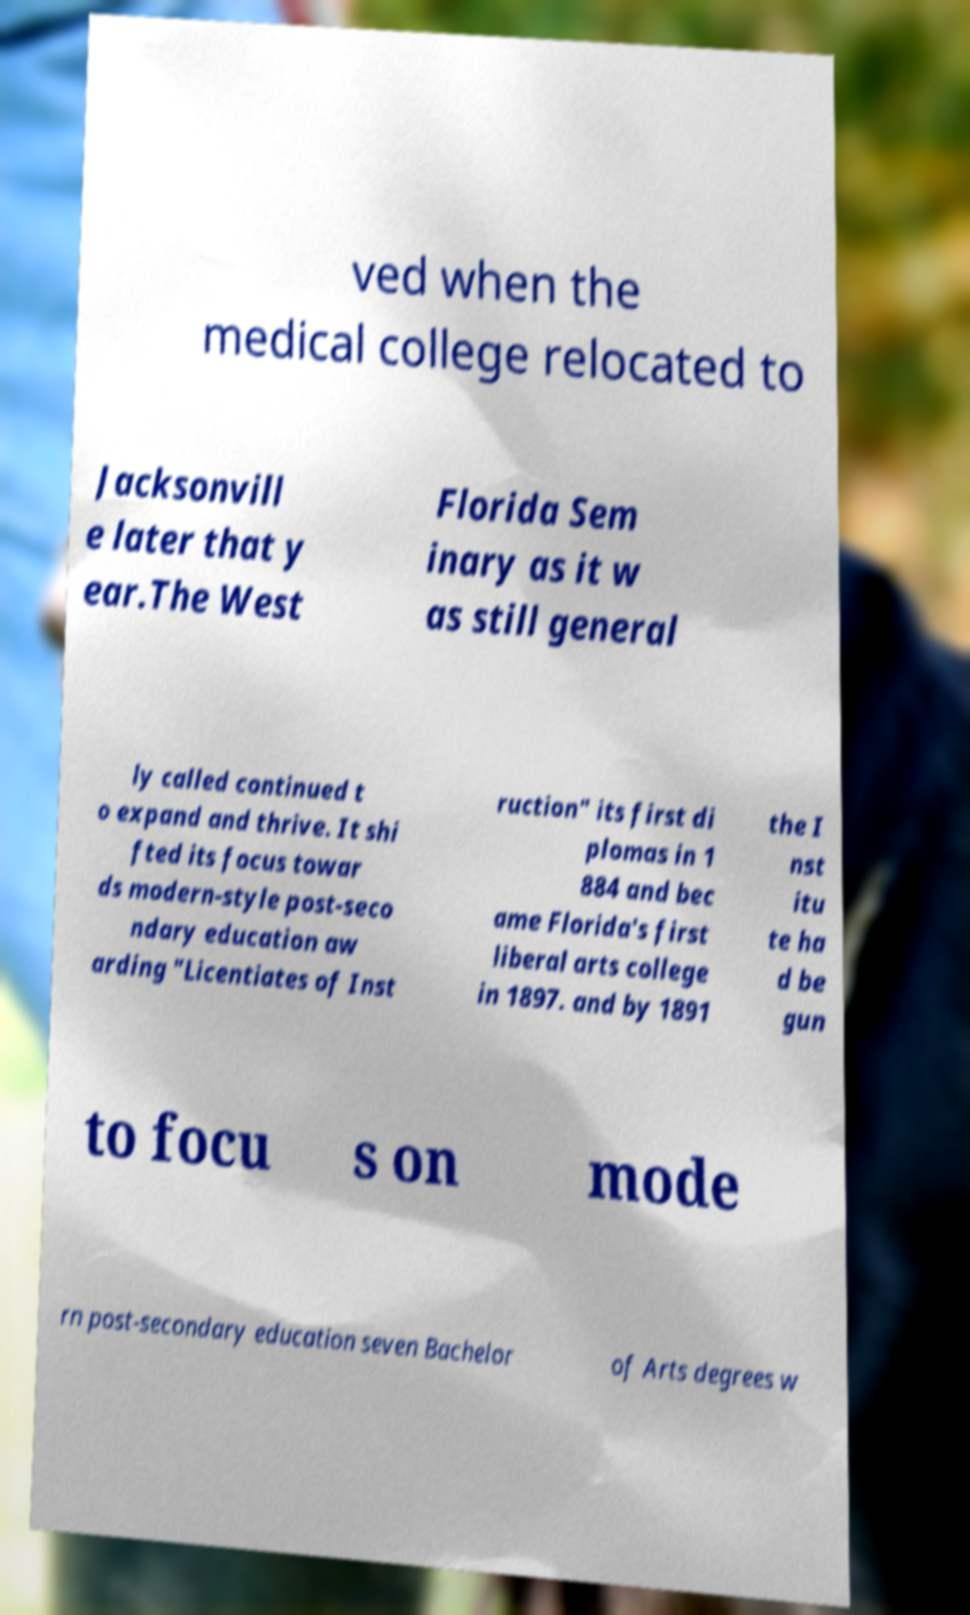There's text embedded in this image that I need extracted. Can you transcribe it verbatim? ved when the medical college relocated to Jacksonvill e later that y ear.The West Florida Sem inary as it w as still general ly called continued t o expand and thrive. It shi fted its focus towar ds modern-style post-seco ndary education aw arding "Licentiates of Inst ruction" its first di plomas in 1 884 and bec ame Florida's first liberal arts college in 1897. and by 1891 the I nst itu te ha d be gun to focu s on mode rn post-secondary education seven Bachelor of Arts degrees w 